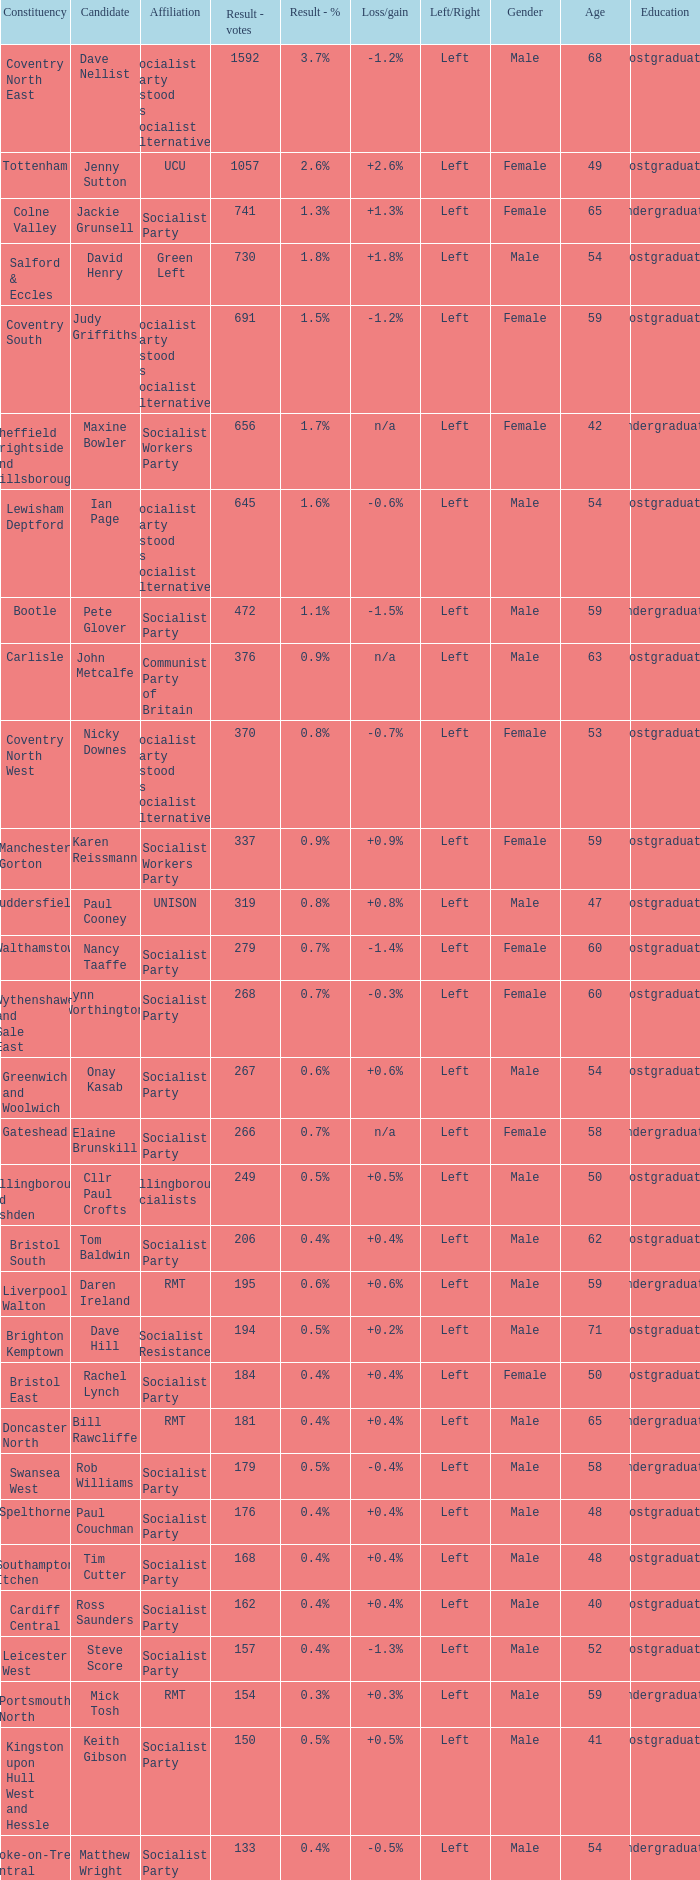What is every candidate for the Cardiff Central constituency? Ross Saunders. 